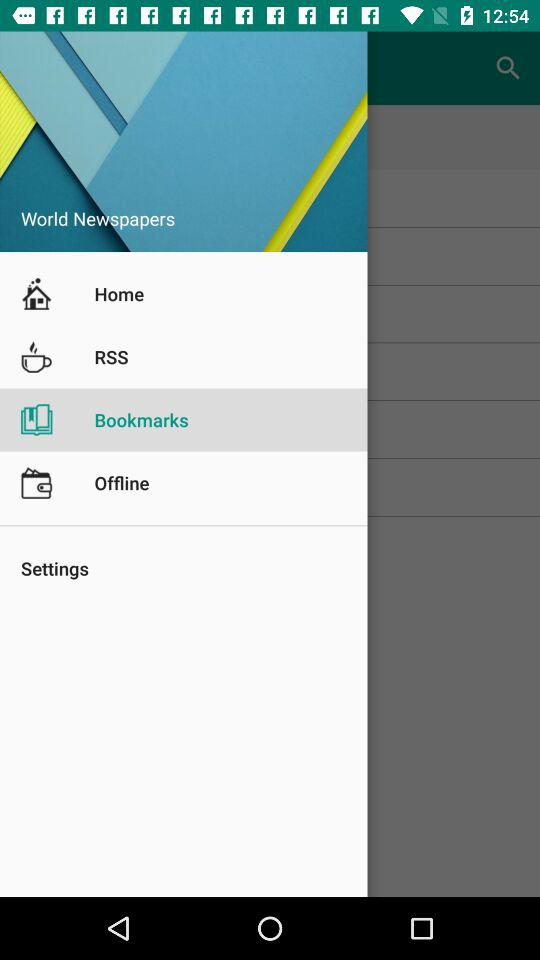What is the app name? The app name is "World Newspapers". 